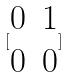<formula> <loc_0><loc_0><loc_500><loc_500>[ \begin{matrix} 0 & 1 \\ 0 & 0 \end{matrix} ]</formula> 